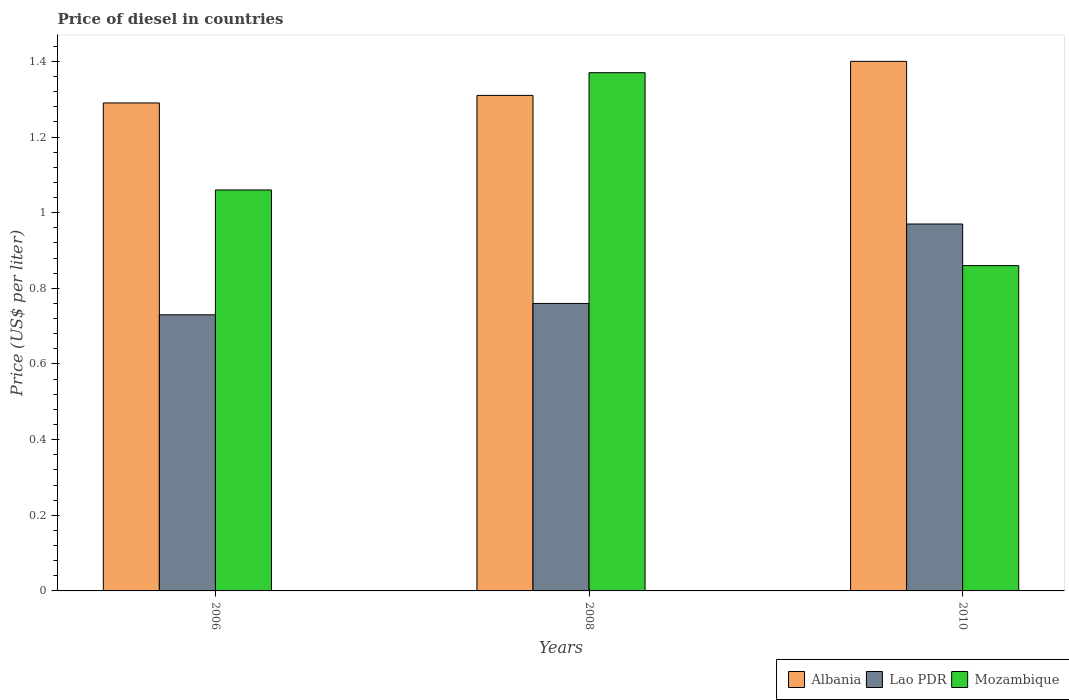How many different coloured bars are there?
Offer a very short reply. 3. How many groups of bars are there?
Provide a succinct answer. 3. Are the number of bars on each tick of the X-axis equal?
Ensure brevity in your answer.  Yes. How many bars are there on the 3rd tick from the left?
Make the answer very short. 3. What is the label of the 3rd group of bars from the left?
Give a very brief answer. 2010. What is the price of diesel in Albania in 2010?
Provide a short and direct response. 1.4. Across all years, what is the minimum price of diesel in Albania?
Your response must be concise. 1.29. What is the total price of diesel in Mozambique in the graph?
Provide a succinct answer. 3.29. What is the difference between the price of diesel in Lao PDR in 2006 and that in 2008?
Keep it short and to the point. -0.03. What is the difference between the price of diesel in Mozambique in 2008 and the price of diesel in Albania in 2006?
Ensure brevity in your answer.  0.08. What is the average price of diesel in Albania per year?
Offer a very short reply. 1.33. In the year 2008, what is the difference between the price of diesel in Lao PDR and price of diesel in Albania?
Keep it short and to the point. -0.55. What is the ratio of the price of diesel in Lao PDR in 2006 to that in 2010?
Provide a short and direct response. 0.75. What is the difference between the highest and the second highest price of diesel in Mozambique?
Make the answer very short. 0.31. What is the difference between the highest and the lowest price of diesel in Lao PDR?
Keep it short and to the point. 0.24. Is the sum of the price of diesel in Lao PDR in 2006 and 2010 greater than the maximum price of diesel in Mozambique across all years?
Provide a succinct answer. Yes. What does the 3rd bar from the left in 2006 represents?
Give a very brief answer. Mozambique. What does the 2nd bar from the right in 2008 represents?
Provide a short and direct response. Lao PDR. Is it the case that in every year, the sum of the price of diesel in Lao PDR and price of diesel in Albania is greater than the price of diesel in Mozambique?
Offer a terse response. Yes. Are all the bars in the graph horizontal?
Offer a terse response. No. What is the difference between two consecutive major ticks on the Y-axis?
Provide a short and direct response. 0.2. Are the values on the major ticks of Y-axis written in scientific E-notation?
Your response must be concise. No. Does the graph contain any zero values?
Ensure brevity in your answer.  No. Where does the legend appear in the graph?
Give a very brief answer. Bottom right. How many legend labels are there?
Offer a very short reply. 3. How are the legend labels stacked?
Give a very brief answer. Horizontal. What is the title of the graph?
Your answer should be compact. Price of diesel in countries. What is the label or title of the X-axis?
Provide a short and direct response. Years. What is the label or title of the Y-axis?
Ensure brevity in your answer.  Price (US$ per liter). What is the Price (US$ per liter) of Albania in 2006?
Keep it short and to the point. 1.29. What is the Price (US$ per liter) of Lao PDR in 2006?
Offer a terse response. 0.73. What is the Price (US$ per liter) in Mozambique in 2006?
Keep it short and to the point. 1.06. What is the Price (US$ per liter) of Albania in 2008?
Your response must be concise. 1.31. What is the Price (US$ per liter) in Lao PDR in 2008?
Offer a terse response. 0.76. What is the Price (US$ per liter) of Mozambique in 2008?
Provide a succinct answer. 1.37. What is the Price (US$ per liter) in Albania in 2010?
Provide a succinct answer. 1.4. What is the Price (US$ per liter) in Lao PDR in 2010?
Offer a terse response. 0.97. What is the Price (US$ per liter) in Mozambique in 2010?
Keep it short and to the point. 0.86. Across all years, what is the maximum Price (US$ per liter) in Albania?
Provide a short and direct response. 1.4. Across all years, what is the maximum Price (US$ per liter) of Lao PDR?
Offer a very short reply. 0.97. Across all years, what is the maximum Price (US$ per liter) of Mozambique?
Your answer should be compact. 1.37. Across all years, what is the minimum Price (US$ per liter) of Albania?
Ensure brevity in your answer.  1.29. Across all years, what is the minimum Price (US$ per liter) of Lao PDR?
Your response must be concise. 0.73. Across all years, what is the minimum Price (US$ per liter) of Mozambique?
Provide a succinct answer. 0.86. What is the total Price (US$ per liter) in Lao PDR in the graph?
Give a very brief answer. 2.46. What is the total Price (US$ per liter) in Mozambique in the graph?
Your answer should be compact. 3.29. What is the difference between the Price (US$ per liter) of Albania in 2006 and that in 2008?
Offer a very short reply. -0.02. What is the difference between the Price (US$ per liter) of Lao PDR in 2006 and that in 2008?
Give a very brief answer. -0.03. What is the difference between the Price (US$ per liter) in Mozambique in 2006 and that in 2008?
Provide a succinct answer. -0.31. What is the difference between the Price (US$ per liter) of Albania in 2006 and that in 2010?
Provide a succinct answer. -0.11. What is the difference between the Price (US$ per liter) of Lao PDR in 2006 and that in 2010?
Keep it short and to the point. -0.24. What is the difference between the Price (US$ per liter) in Albania in 2008 and that in 2010?
Offer a terse response. -0.09. What is the difference between the Price (US$ per liter) of Lao PDR in 2008 and that in 2010?
Offer a very short reply. -0.21. What is the difference between the Price (US$ per liter) of Mozambique in 2008 and that in 2010?
Provide a short and direct response. 0.51. What is the difference between the Price (US$ per liter) in Albania in 2006 and the Price (US$ per liter) in Lao PDR in 2008?
Provide a succinct answer. 0.53. What is the difference between the Price (US$ per liter) in Albania in 2006 and the Price (US$ per liter) in Mozambique in 2008?
Offer a very short reply. -0.08. What is the difference between the Price (US$ per liter) in Lao PDR in 2006 and the Price (US$ per liter) in Mozambique in 2008?
Offer a very short reply. -0.64. What is the difference between the Price (US$ per liter) in Albania in 2006 and the Price (US$ per liter) in Lao PDR in 2010?
Offer a very short reply. 0.32. What is the difference between the Price (US$ per liter) of Albania in 2006 and the Price (US$ per liter) of Mozambique in 2010?
Ensure brevity in your answer.  0.43. What is the difference between the Price (US$ per liter) of Lao PDR in 2006 and the Price (US$ per liter) of Mozambique in 2010?
Keep it short and to the point. -0.13. What is the difference between the Price (US$ per liter) of Albania in 2008 and the Price (US$ per liter) of Lao PDR in 2010?
Your answer should be compact. 0.34. What is the difference between the Price (US$ per liter) in Albania in 2008 and the Price (US$ per liter) in Mozambique in 2010?
Your answer should be very brief. 0.45. What is the difference between the Price (US$ per liter) of Lao PDR in 2008 and the Price (US$ per liter) of Mozambique in 2010?
Offer a very short reply. -0.1. What is the average Price (US$ per liter) in Albania per year?
Keep it short and to the point. 1.33. What is the average Price (US$ per liter) of Lao PDR per year?
Your answer should be compact. 0.82. What is the average Price (US$ per liter) of Mozambique per year?
Keep it short and to the point. 1.1. In the year 2006, what is the difference between the Price (US$ per liter) in Albania and Price (US$ per liter) in Lao PDR?
Keep it short and to the point. 0.56. In the year 2006, what is the difference between the Price (US$ per liter) of Albania and Price (US$ per liter) of Mozambique?
Give a very brief answer. 0.23. In the year 2006, what is the difference between the Price (US$ per liter) of Lao PDR and Price (US$ per liter) of Mozambique?
Your answer should be compact. -0.33. In the year 2008, what is the difference between the Price (US$ per liter) in Albania and Price (US$ per liter) in Lao PDR?
Offer a terse response. 0.55. In the year 2008, what is the difference between the Price (US$ per liter) in Albania and Price (US$ per liter) in Mozambique?
Provide a short and direct response. -0.06. In the year 2008, what is the difference between the Price (US$ per liter) in Lao PDR and Price (US$ per liter) in Mozambique?
Provide a succinct answer. -0.61. In the year 2010, what is the difference between the Price (US$ per liter) in Albania and Price (US$ per liter) in Lao PDR?
Your response must be concise. 0.43. In the year 2010, what is the difference between the Price (US$ per liter) of Albania and Price (US$ per liter) of Mozambique?
Give a very brief answer. 0.54. In the year 2010, what is the difference between the Price (US$ per liter) of Lao PDR and Price (US$ per liter) of Mozambique?
Provide a succinct answer. 0.11. What is the ratio of the Price (US$ per liter) of Albania in 2006 to that in 2008?
Ensure brevity in your answer.  0.98. What is the ratio of the Price (US$ per liter) of Lao PDR in 2006 to that in 2008?
Give a very brief answer. 0.96. What is the ratio of the Price (US$ per liter) in Mozambique in 2006 to that in 2008?
Keep it short and to the point. 0.77. What is the ratio of the Price (US$ per liter) in Albania in 2006 to that in 2010?
Offer a terse response. 0.92. What is the ratio of the Price (US$ per liter) in Lao PDR in 2006 to that in 2010?
Your answer should be very brief. 0.75. What is the ratio of the Price (US$ per liter) of Mozambique in 2006 to that in 2010?
Offer a very short reply. 1.23. What is the ratio of the Price (US$ per liter) of Albania in 2008 to that in 2010?
Provide a succinct answer. 0.94. What is the ratio of the Price (US$ per liter) in Lao PDR in 2008 to that in 2010?
Make the answer very short. 0.78. What is the ratio of the Price (US$ per liter) of Mozambique in 2008 to that in 2010?
Your answer should be very brief. 1.59. What is the difference between the highest and the second highest Price (US$ per liter) of Albania?
Provide a short and direct response. 0.09. What is the difference between the highest and the second highest Price (US$ per liter) in Lao PDR?
Offer a terse response. 0.21. What is the difference between the highest and the second highest Price (US$ per liter) in Mozambique?
Your response must be concise. 0.31. What is the difference between the highest and the lowest Price (US$ per liter) of Albania?
Ensure brevity in your answer.  0.11. What is the difference between the highest and the lowest Price (US$ per liter) of Lao PDR?
Your answer should be compact. 0.24. What is the difference between the highest and the lowest Price (US$ per liter) of Mozambique?
Your answer should be very brief. 0.51. 